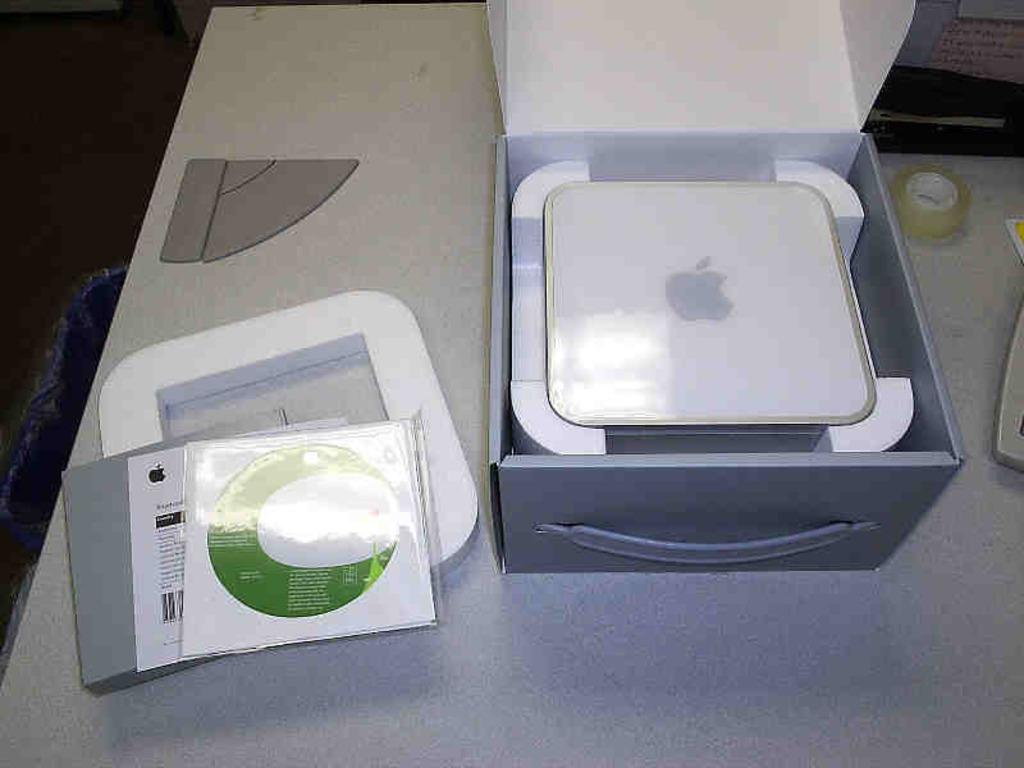What type of objects can be seen on the table in the image? There are books, paper, and a box on the table in the image. What might the books and paper be used for? The books and paper might be used for reading, writing, or studying. What is the purpose of the box in the image? The purpose of the box in the image is not clear, but it could be used for storage or organization. What type of party is being held in the image? There is no party present in the image; it only shows books, paper, and a box on a table. How many toes are visible in the image? There are no visible toes in the image, as it only features books, paper, and a box on a table. 